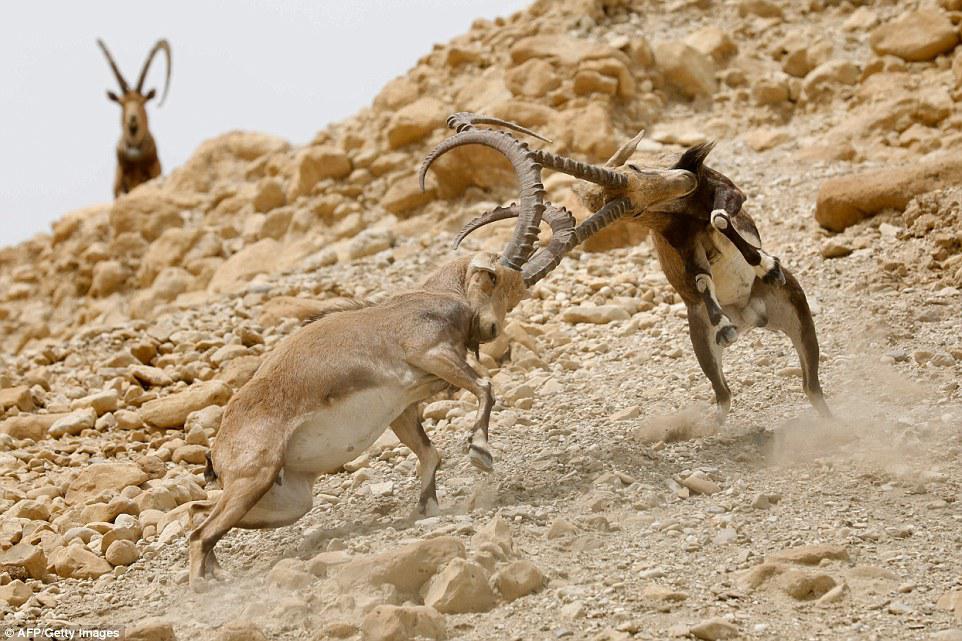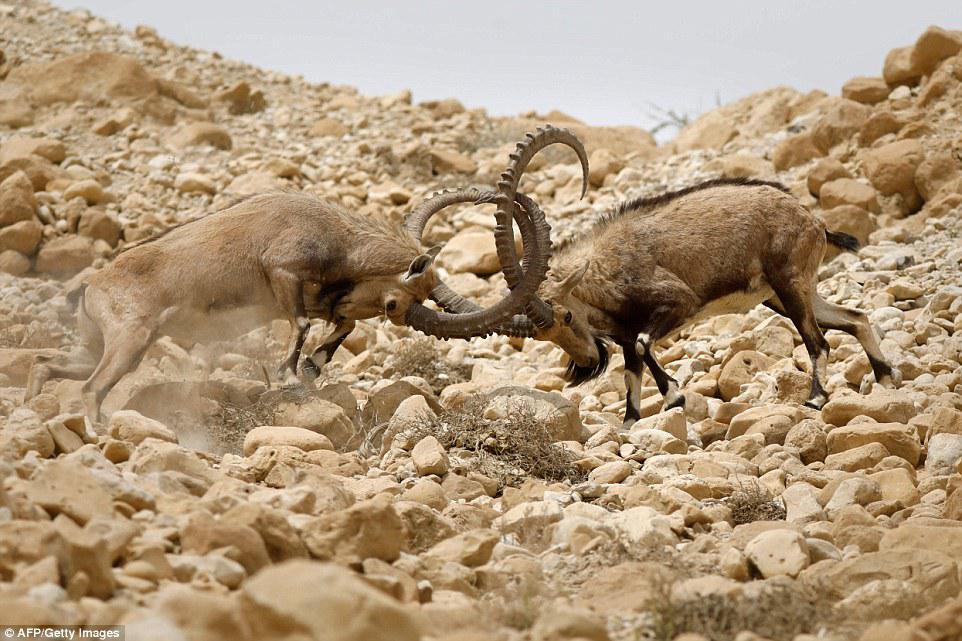The first image is the image on the left, the second image is the image on the right. Considering the images on both sides, is "There is exactly two mountain goats in the right image." valid? Answer yes or no. Yes. The first image is the image on the left, the second image is the image on the right. For the images shown, is this caption "The left and right image contains the total  of five rams." true? Answer yes or no. Yes. 